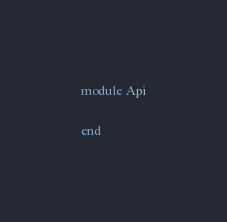<code> <loc_0><loc_0><loc_500><loc_500><_Ruby_>module Api

end
</code> 